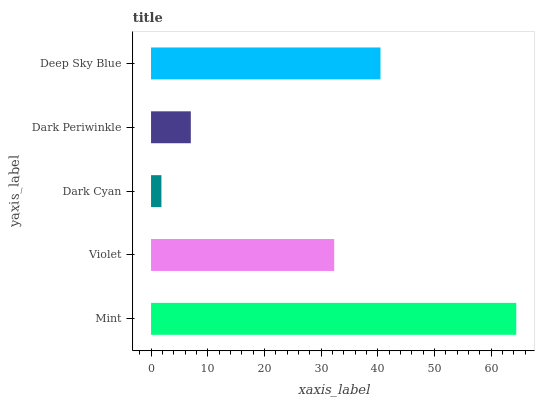Is Dark Cyan the minimum?
Answer yes or no. Yes. Is Mint the maximum?
Answer yes or no. Yes. Is Violet the minimum?
Answer yes or no. No. Is Violet the maximum?
Answer yes or no. No. Is Mint greater than Violet?
Answer yes or no. Yes. Is Violet less than Mint?
Answer yes or no. Yes. Is Violet greater than Mint?
Answer yes or no. No. Is Mint less than Violet?
Answer yes or no. No. Is Violet the high median?
Answer yes or no. Yes. Is Violet the low median?
Answer yes or no. Yes. Is Dark Cyan the high median?
Answer yes or no. No. Is Mint the low median?
Answer yes or no. No. 